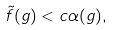<formula> <loc_0><loc_0><loc_500><loc_500>\tilde { f } ( g ) < c \alpha ( g ) ,</formula> 